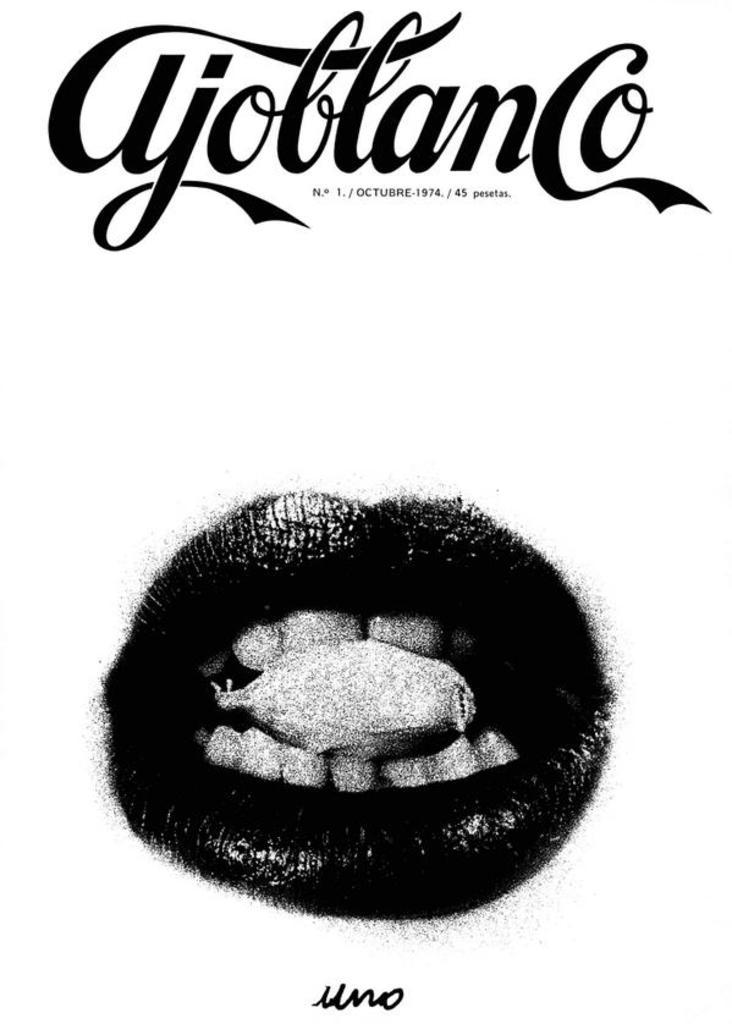What is present in the image? There is a poster in the image. What is depicted on the poster? The poster contains an image of a mouth. What type of border is around the mouth on the poster? There is no mention of a border around the mouth on the poster, so it cannot be determined from the image. 